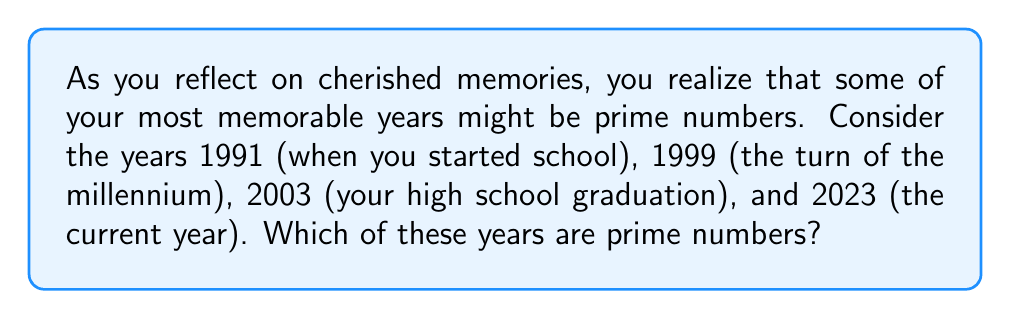What is the answer to this math problem? To determine which years are prime numbers, we need to check if each year is divisible only by 1 and itself. Let's examine each year:

1. 1991:
   To check if 1991 is prime, we need to test divisibility up to $\sqrt{1991} \approx 44.62$. 
   $1991 = 11 \times 181$
   Therefore, 1991 is not a prime number.

2. 1999:
   $\sqrt{1999} \approx 44.71$
   After checking divisibility by prime numbers up to 44, we find that 1999 is not divisible by any of them.
   Therefore, 1999 is a prime number.

3. 2003:
   $\sqrt{2003} \approx 44.75$
   After checking divisibility by prime numbers up to 44, we find that 2003 is not divisible by any of them.
   Therefore, 2003 is a prime number.

4. 2023:
   $\sqrt{2023} \approx 44.98$
   $2023 = 7 \times 289$
   Therefore, 2023 is not a prime number.
Answer: The prime numbers among the given years are 1999 and 2003. 